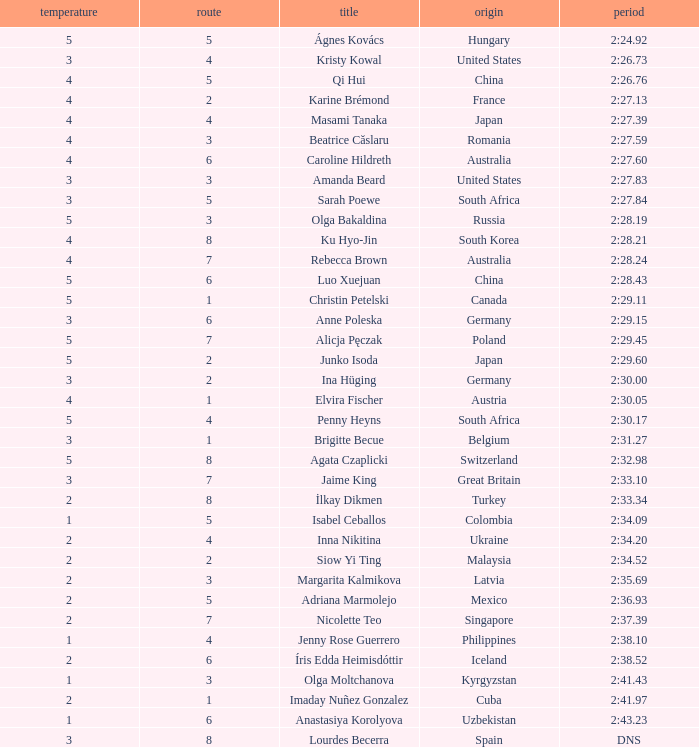What route did inna nikitina take? 4.0. 